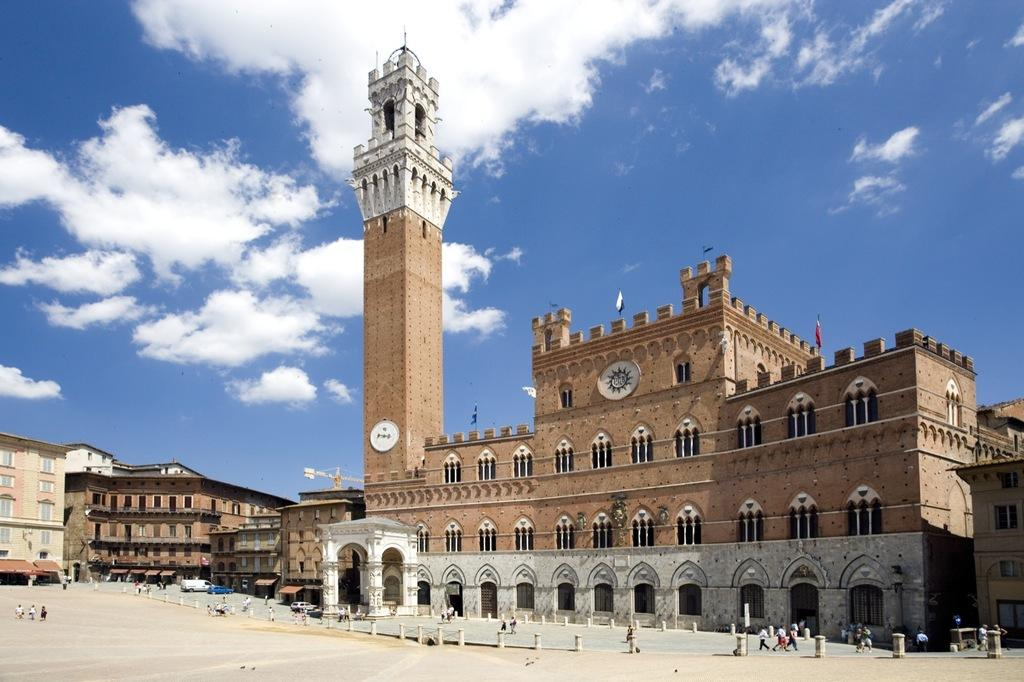What type of structures can be seen in the image? There are buildings, a tower, walls, and pillars in the image. What architectural features are present on the structures? There are windows and flags visible on the structures. Who or what is present at the bottom of the image? There are people at the bottom of the image. What can be seen in the background of the image? The sky is visible in the background of the image. What type of ornament is being used to clean the windows in the image? There is no ornament or cleaning activity depicted in the image. Can you hear the drum being played in the image? There is no drum or sound present in the image. 